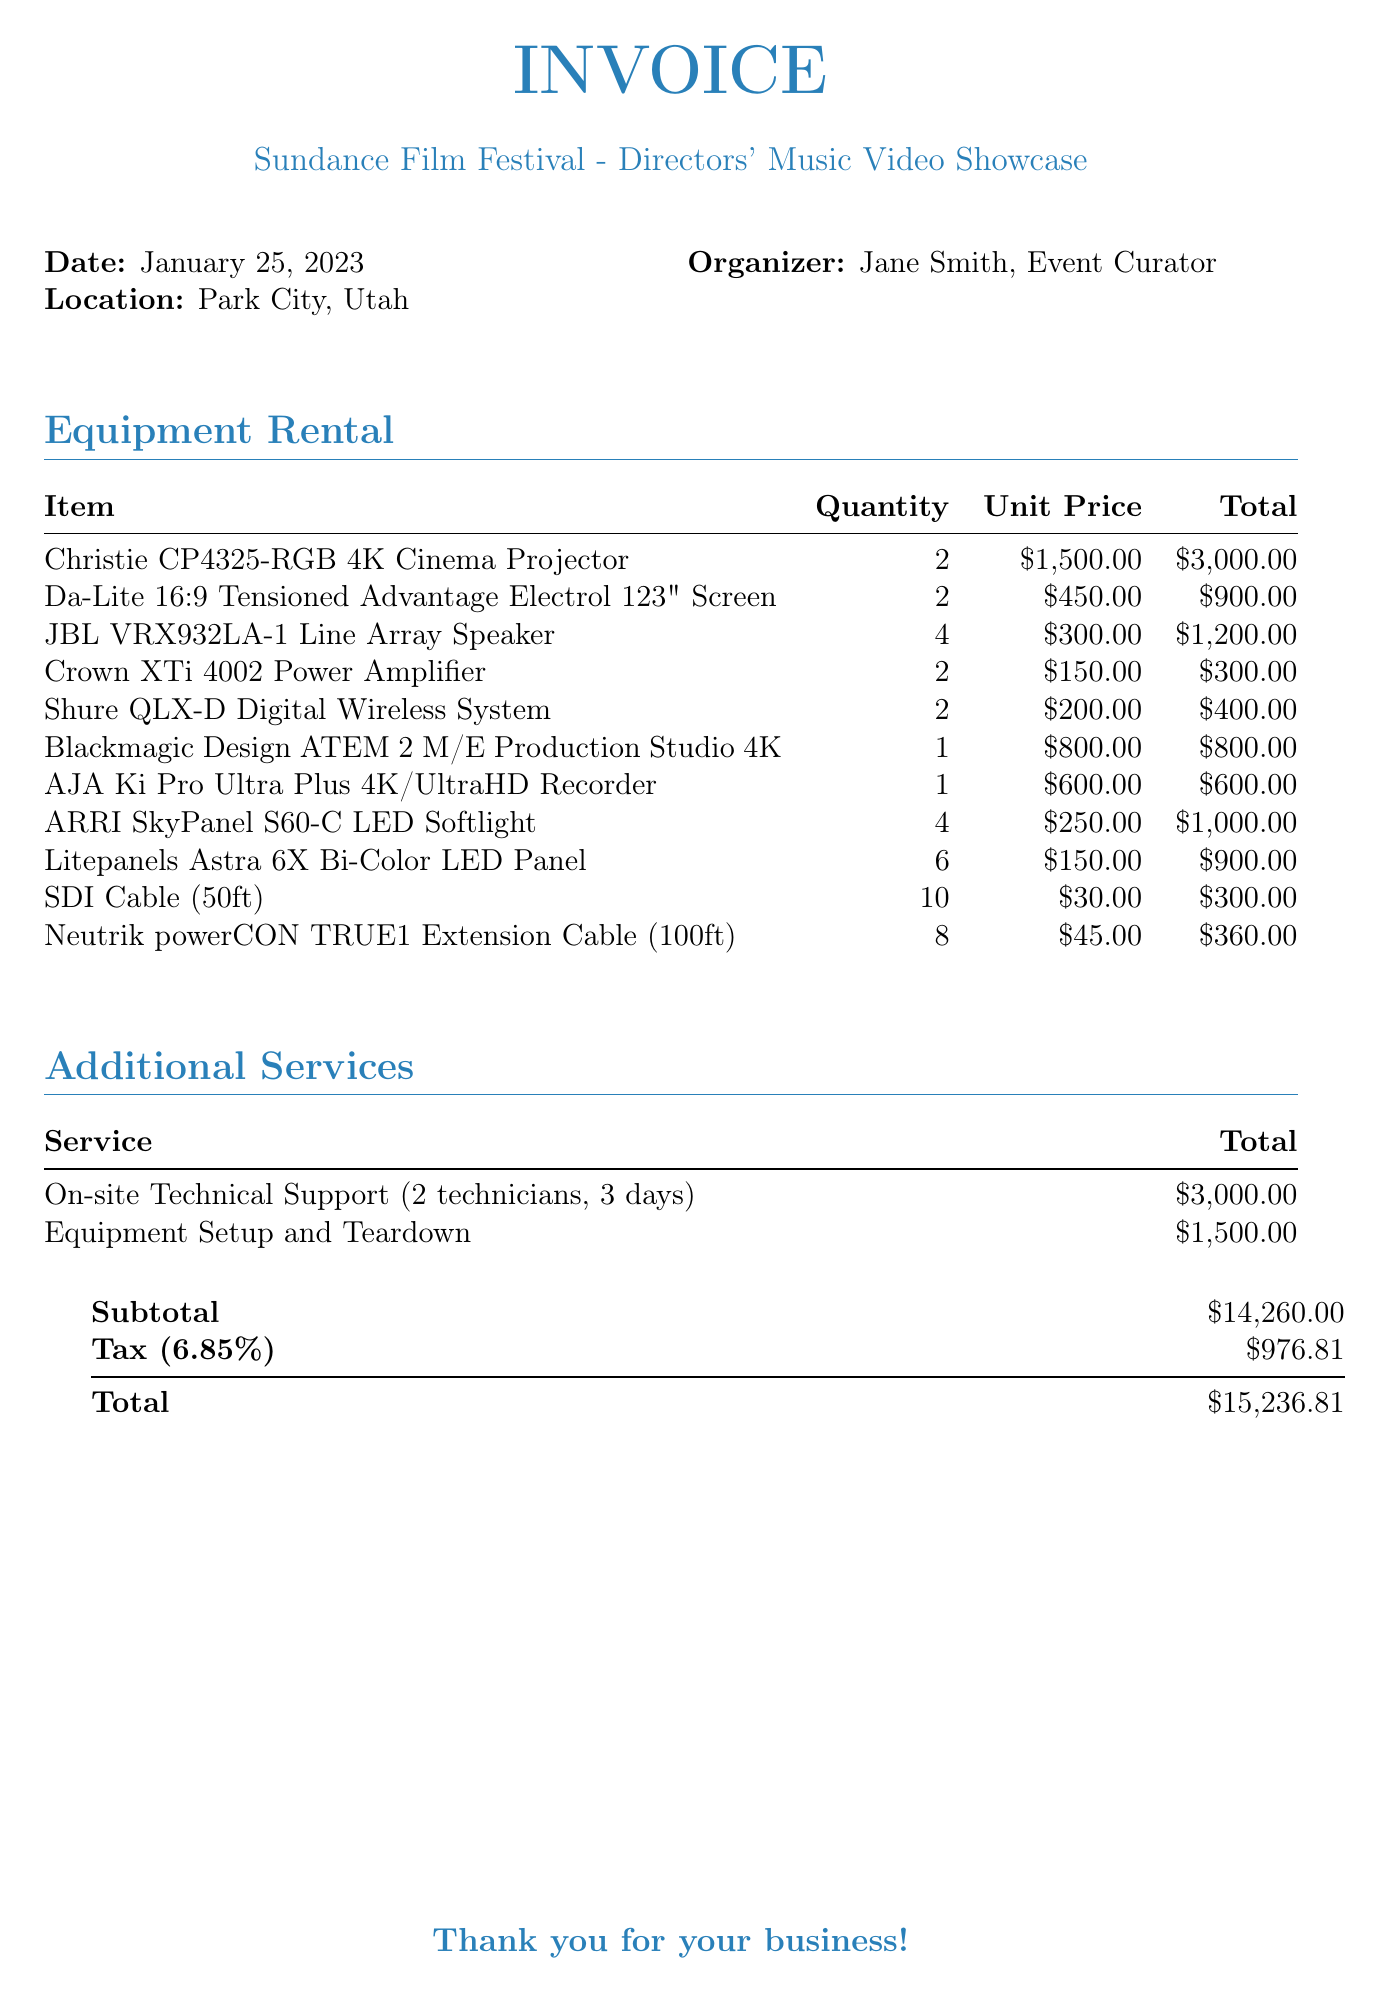What is the event name? The event name is listed in the document as the Sundance Film Festival - Directors' Music Video Showcase.
Answer: Sundance Film Festival - Directors' Music Video Showcase What is the date of the event? The date of the event is explicitly mentioned in the document.
Answer: January 25, 2023 How many Christie CP4325-RGB projectors are rented? The document specifies the quantity of Christie CP4325-RGB projectors that are rented.
Answer: 2 What is the total cost of the Audio equipment category? To find this, sum the total costs of all items listed under the Audio category in the document.
Answer: 1,900 What additional service includes on-site technicians? The document lists a service that specifically mentions on-site technical support with technicians.
Answer: On-site Technical Support (2 technicians) What is the subtotal amount? The subtotal amount is clearly stated in the summary section of the invoice.
Answer: 14,260.00 What is the tax rate applied? The document provides the tax rate that has been applied to the subtotal amount.
Answer: 6.85% How many items are listed under Accessories? The number of items listed under Accessories can be counted from the document.
Answer: 2 What is the total amount due? The total amount due is the final figure presented at the bottom of the invoice.
Answer: 15,236.81 